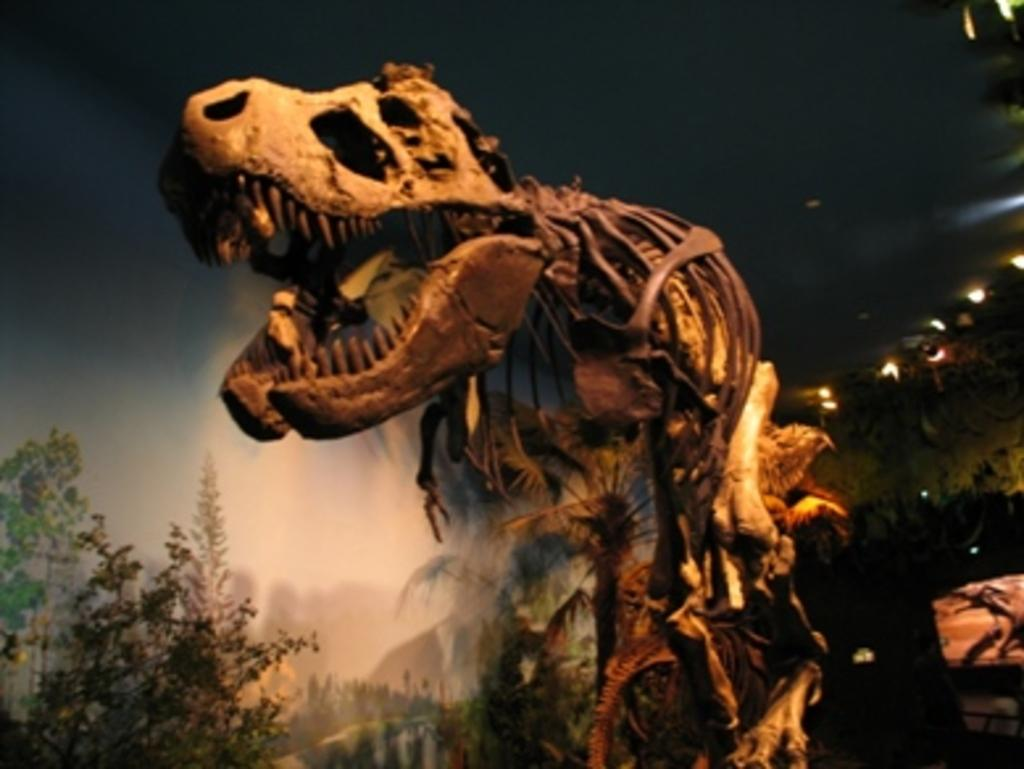What is the main subject of the image? The main subject of the image is a skeleton of a dragon. What can be seen in the background of the image? There are trees in the background of the image. What is the wealth of the laborer depicted in the image? There is no laborer present in the image, and therefore no wealth can be attributed to them. 